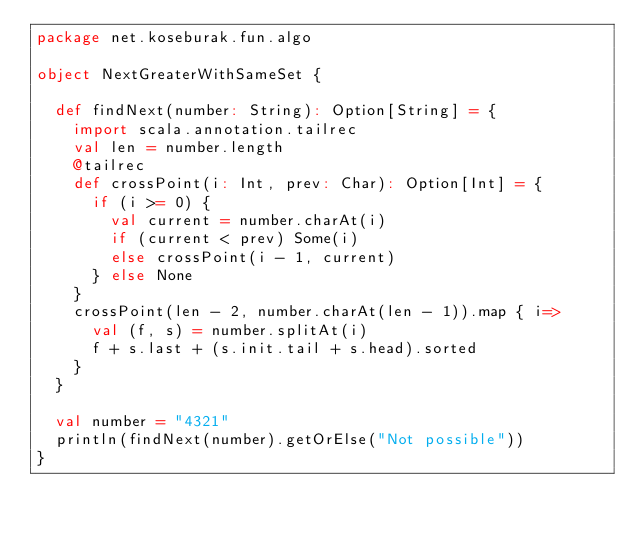<code> <loc_0><loc_0><loc_500><loc_500><_Scala_>package net.koseburak.fun.algo

object NextGreaterWithSameSet {

  def findNext(number: String): Option[String] = {
    import scala.annotation.tailrec
    val len = number.length
    @tailrec
    def crossPoint(i: Int, prev: Char): Option[Int] = {
      if (i >= 0) {
        val current = number.charAt(i)
        if (current < prev) Some(i)
        else crossPoint(i - 1, current)
      } else None
    }
    crossPoint(len - 2, number.charAt(len - 1)).map { i=>
      val (f, s) = number.splitAt(i)
      f + s.last + (s.init.tail + s.head).sorted
    }
  }

  val number = "4321"
  println(findNext(number).getOrElse("Not possible"))
}
</code> 